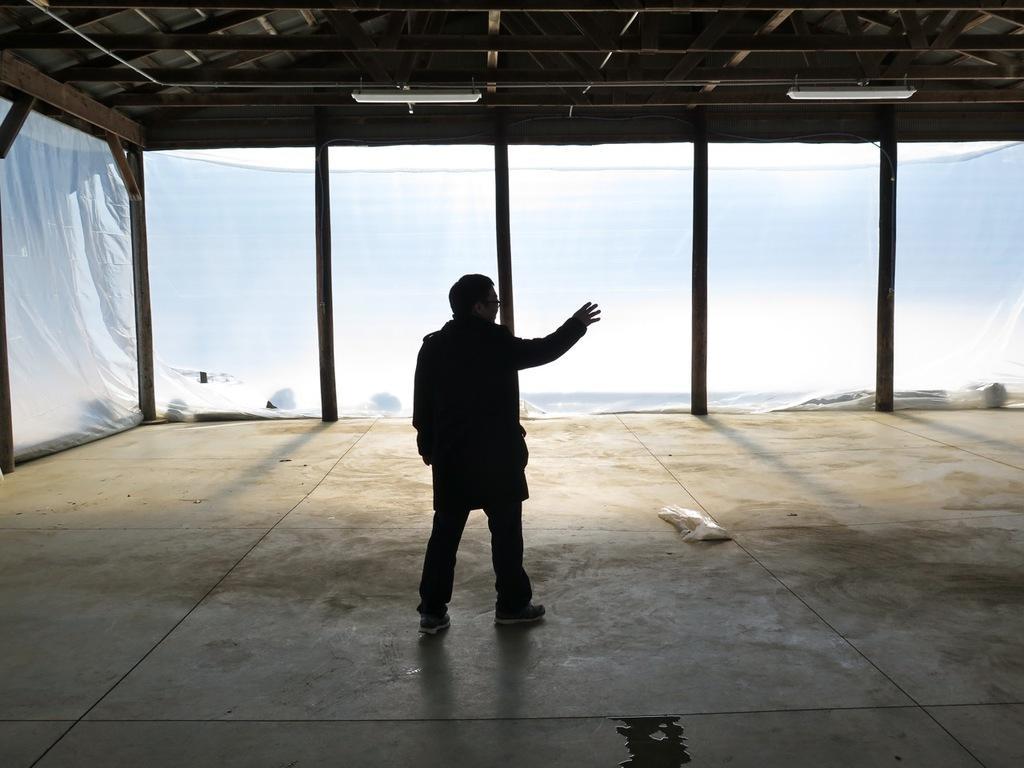How would you summarize this image in a sentence or two? In this image we can see a person standing on the floor. On the backside we can see some windows and a roof with some ceiling lights. 